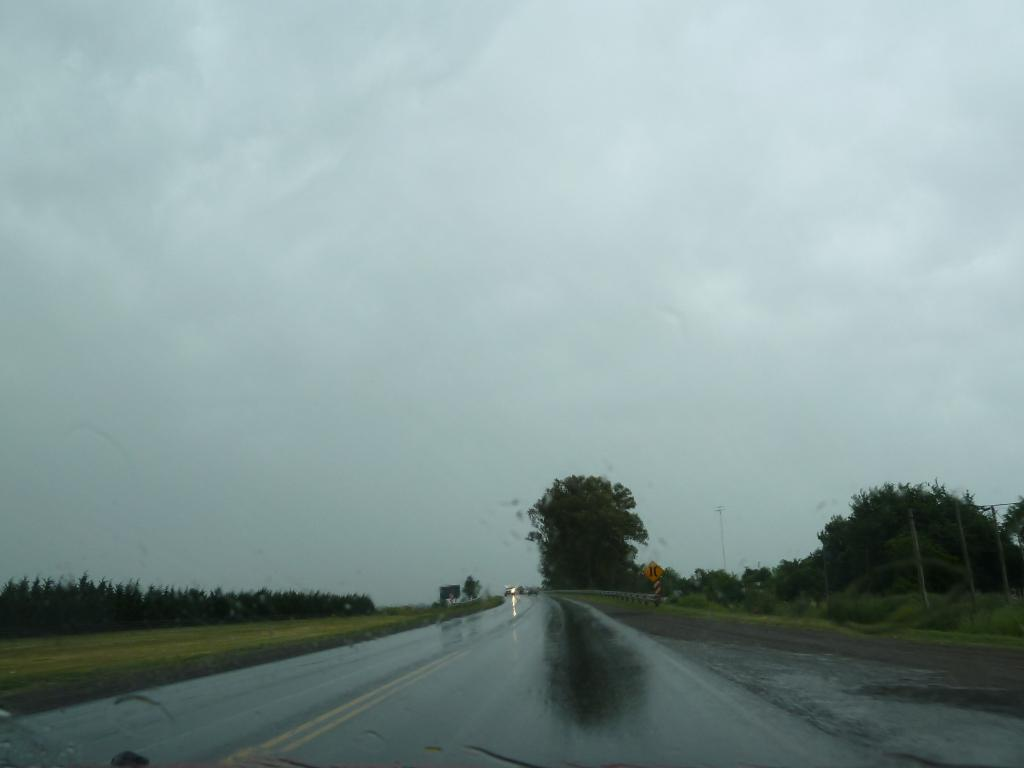What is the main feature of the image? There is a road in the image. What can be seen alongside the road? There are plants on either side of the road. Where are the plants located? The plants are on the ground. What is visible in the background of the image? There are trees and clouds in the sky in the background of the image. Reasoning: Let'g: Let's think step by step in order to produce the conversation. We start by identifying the main subject of the image, which is the road. Then, we describe the surroundings of the road, including the plants on either side. We also mention the location of the plants, which are on the ground. Finally, we expand the conversation to include the background of the image, which features trees and clouds in the sky. Absurd Question/Answer: How does the nail affect the appearance of the road in the image? There is no nail present in the image, so it does not affect the appearance of the road. 